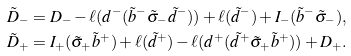Convert formula to latex. <formula><loc_0><loc_0><loc_500><loc_500>\tilde { D } _ { - } & = D _ { - } - \ell ( d ^ { - } ( \tilde { b } ^ { - } \tilde { \sigma } _ { - } \tilde { d } ^ { - } ) ) + \ell ( \tilde { d } ^ { - } ) + I _ { - } ( \tilde { b } ^ { - } \tilde { \sigma } _ { - } ) , \\ \tilde { D } _ { + } & = I _ { + } ( \tilde { \sigma } _ { + } \tilde { b } ^ { + } ) + \ell ( \tilde { d } ^ { + } ) - \ell ( d ^ { + } ( \tilde { d } ^ { + } \tilde { \sigma } _ { + } \tilde { b } ^ { + } ) ) + D _ { + } .</formula> 